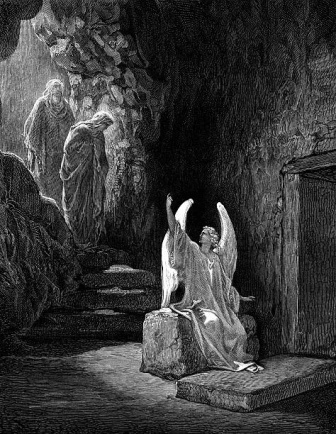How might this illustration fit into a larger narrative or story? Provide a brief plot. This illustration could be a pivotal scene in a larger narrative about a journey of spiritual awakening. The story might follow a group of pilgrims or seekers who venture into the depths of a sacred cave to seek wisdom and guidance. The angel they encounter represents a divine emissary, appearing to deliver a crucial message or reveal hidden truths. The wooden door on the right could lead to further chambers where additional trials, visions, or revelations await. The plot could involve the pilgrims' quest to understand the angel's message, overcome obstacles within the cave, and ultimately emerge transformed by their experiences, carrying newfound knowledge and purpose back to the outside world. What might be behind the wooden door in the illustration? Behind the wooden door, there could be deeper chambers of the cave filled with ancient carvings, sacred relics, and further mysteries to uncover. It might lead to a hidden sanctuary where the pilgrims find additional divine messages, or perhaps a vast underground network of tunnels that challenge their resolve and unity. Alternatively, the door could open into a different realm entirely, a mystical landscape where the boundaries between the earthly and divine blur, offering the seekers new worlds to explore and deeper understandings to gain. 